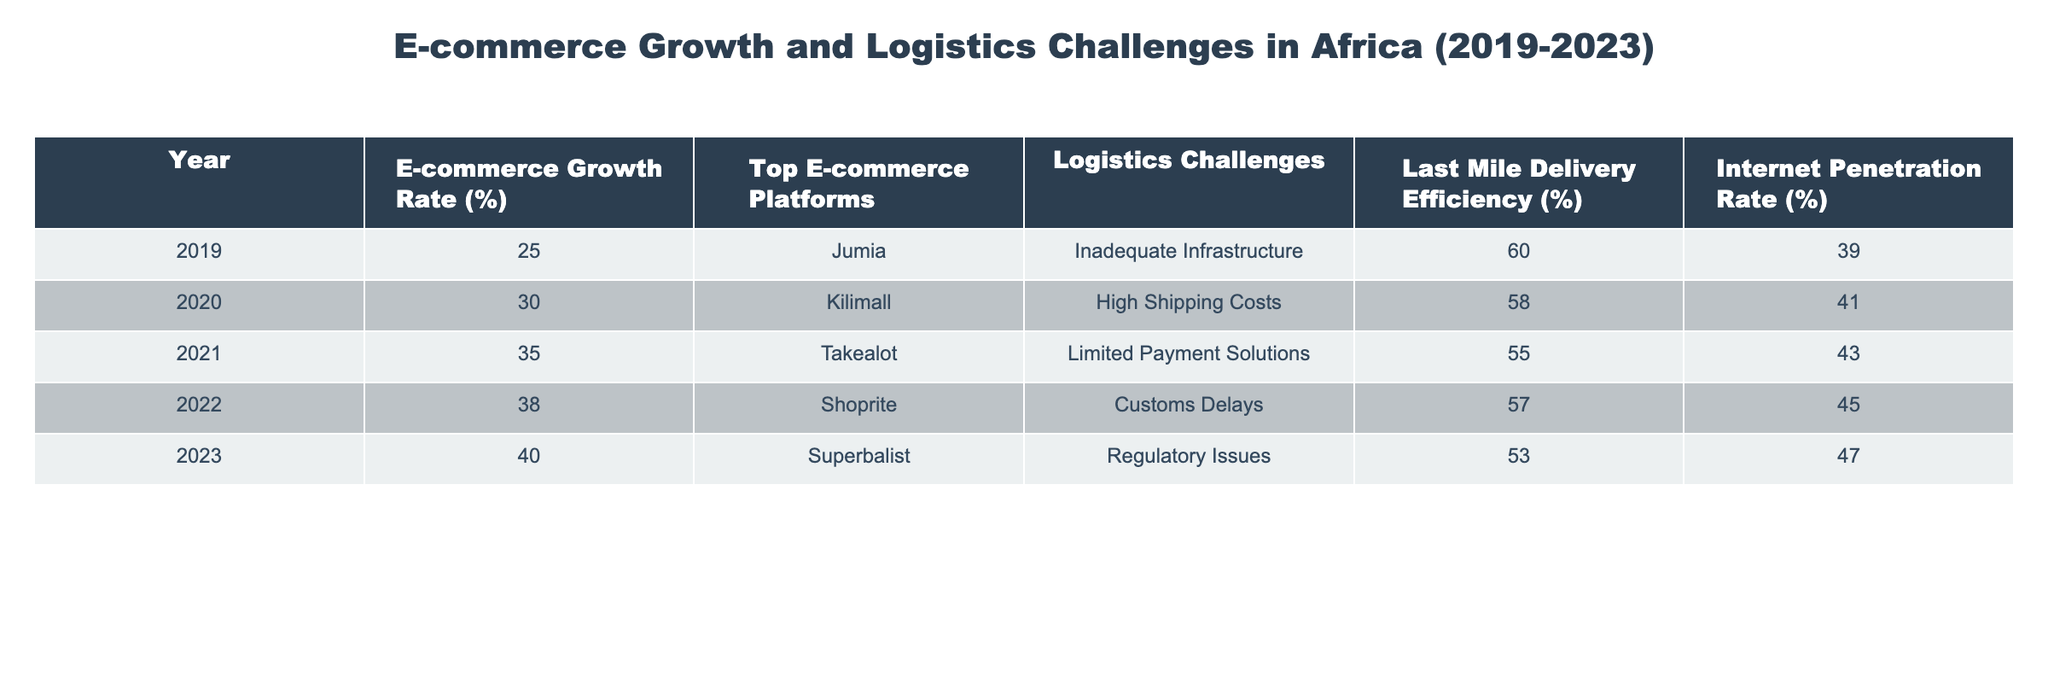What was the e-commerce growth rate in 2021? The table shows the e-commerce growth rate for each year from 2019 to 2023. In 2021, the rate is specifically listed as 35%.
Answer: 35% What were the top e-commerce platforms in 2020? By looking at the column for top e-commerce platforms, in the year 2020, the platform mentioned is Kilimall.
Answer: Kilimall What is the average last mile delivery efficiency over the five years? To find the average, sum the last mile delivery efficiencies: (60 + 58 + 55 + 57 + 53) = 283. There are 5 years, so the average is 283 / 5 = 56.6%.
Answer: 56.6% Did internet penetration increase every year from 2019 to 2023? By checking the internet penetration rates for each year, we see they are 39%, 41%, 43%, 45%, and 47%, respectively. This indicates a consistent increase over the years.
Answer: Yes Which logistics challenge had the highest impact in 2023? The table clearly lists the logistics challenges for each year, and in 2023, the challenge was regulatory issues, indicating that this was the latest and potentially highest impact issue.
Answer: Regulatory Issues What was the percentage increase in e-commerce growth rate from 2022 to 2023? The e-commerce growth rate for 2022 is 38% and for 2023 is 40%. The increase is calculated as 40% - 38% = 2%.
Answer: 2% Which year had the lowest last mile delivery efficiency, and what was that value? By reviewing the last mile delivery efficiency column, we see that 2023 had the lowest efficiency at 53%.
Answer: 53% How many logistics challenges were reported in total from 2019 to 2023? The table lists a different logistics challenge for each year, totaling five unique challenges observed in the five years considered.
Answer: 5 What was the internet penetration rate in the year with the highest e-commerce growth rate? The year with the highest e-commerce growth rate is 2023, which has an internet penetration rate of 47%.
Answer: 47% 